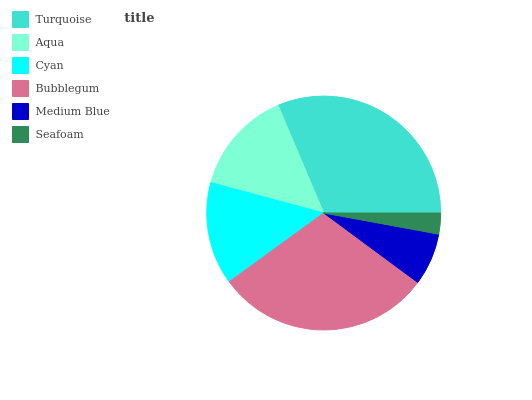Is Seafoam the minimum?
Answer yes or no. Yes. Is Turquoise the maximum?
Answer yes or no. Yes. Is Aqua the minimum?
Answer yes or no. No. Is Aqua the maximum?
Answer yes or no. No. Is Turquoise greater than Aqua?
Answer yes or no. Yes. Is Aqua less than Turquoise?
Answer yes or no. Yes. Is Aqua greater than Turquoise?
Answer yes or no. No. Is Turquoise less than Aqua?
Answer yes or no. No. Is Aqua the high median?
Answer yes or no. Yes. Is Cyan the low median?
Answer yes or no. Yes. Is Seafoam the high median?
Answer yes or no. No. Is Aqua the low median?
Answer yes or no. No. 